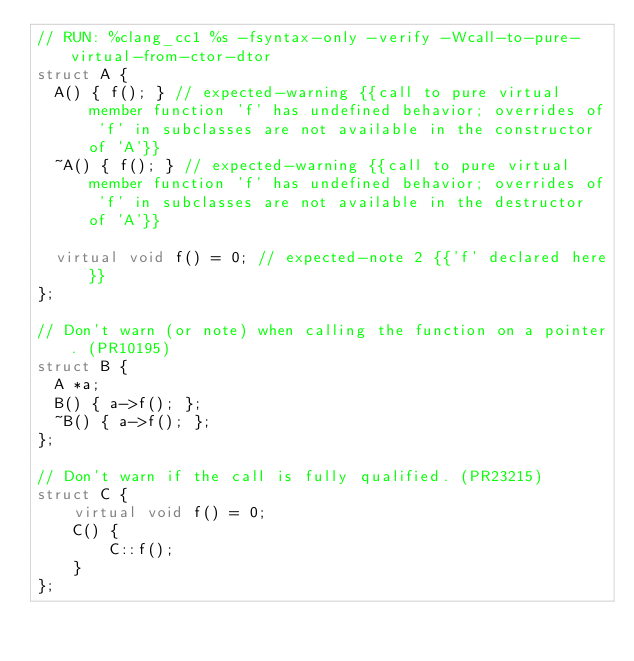Convert code to text. <code><loc_0><loc_0><loc_500><loc_500><_C++_>// RUN: %clang_cc1 %s -fsyntax-only -verify -Wcall-to-pure-virtual-from-ctor-dtor
struct A {
  A() { f(); } // expected-warning {{call to pure virtual member function 'f' has undefined behavior; overrides of 'f' in subclasses are not available in the constructor of 'A'}}
  ~A() { f(); } // expected-warning {{call to pure virtual member function 'f' has undefined behavior; overrides of 'f' in subclasses are not available in the destructor of 'A'}}

  virtual void f() = 0; // expected-note 2 {{'f' declared here}}
};

// Don't warn (or note) when calling the function on a pointer. (PR10195)
struct B {
  A *a;
  B() { a->f(); };
  ~B() { a->f(); };
};

// Don't warn if the call is fully qualified. (PR23215)
struct C {
    virtual void f() = 0;
    C() {
        C::f();
    }
};
</code> 